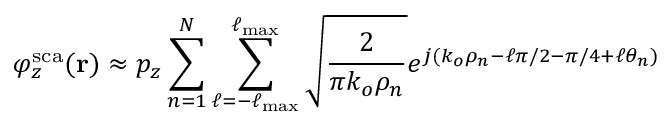<formula> <loc_0><loc_0><loc_500><loc_500>\varphi _ { z } ^ { s c a } ( r ) \approx p _ { z } \sum _ { n = 1 } ^ { N } \sum _ { \ell = - \ell _ { \max } } ^ { \ell _ { \max } } \sqrt { \frac { 2 } { \pi k _ { o } \rho _ { n } } } e ^ { j ( k _ { o } \rho _ { n } - \ell \pi / 2 - \pi / 4 + \ell \theta _ { n } ) }</formula> 